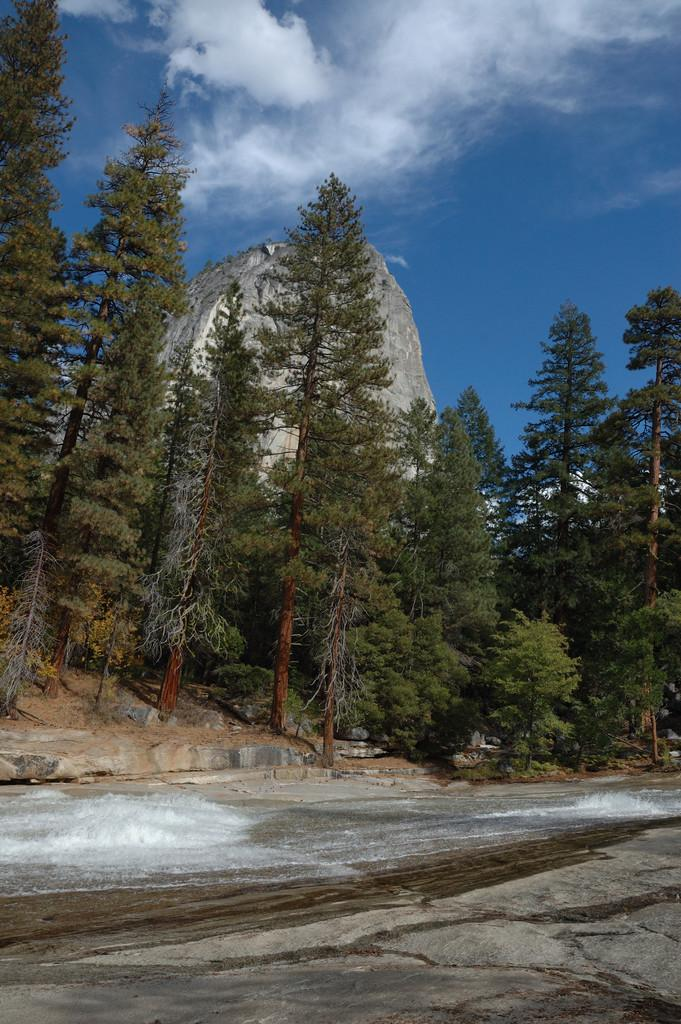What type of vegetation can be seen in the image? There is a group of trees in the image. What geographical feature is present in the image? There is a mountain in the image. How would you describe the sky in the image? The sky is visible in the image and appears cloudy. What is the ground condition in the image? There is snow and water on the ground in the image. What is the opinion of the trees about the snow in the image? Trees do not have opinions, as they are inanimate objects. Can you see any blood on the ground in the image? There is no blood present in the image; it features snow and water on the ground. 